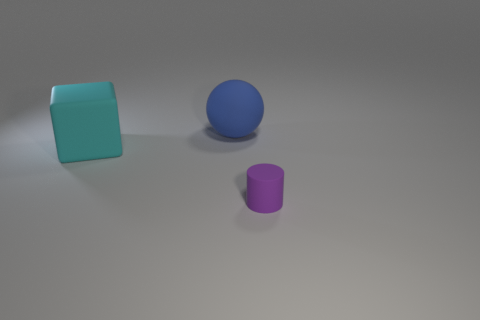Add 1 big objects. How many objects exist? 4 Subtract all blocks. How many objects are left? 2 Subtract 0 purple cubes. How many objects are left? 3 Subtract all purple matte objects. Subtract all big cyan matte objects. How many objects are left? 1 Add 3 matte things. How many matte things are left? 6 Add 2 small things. How many small things exist? 3 